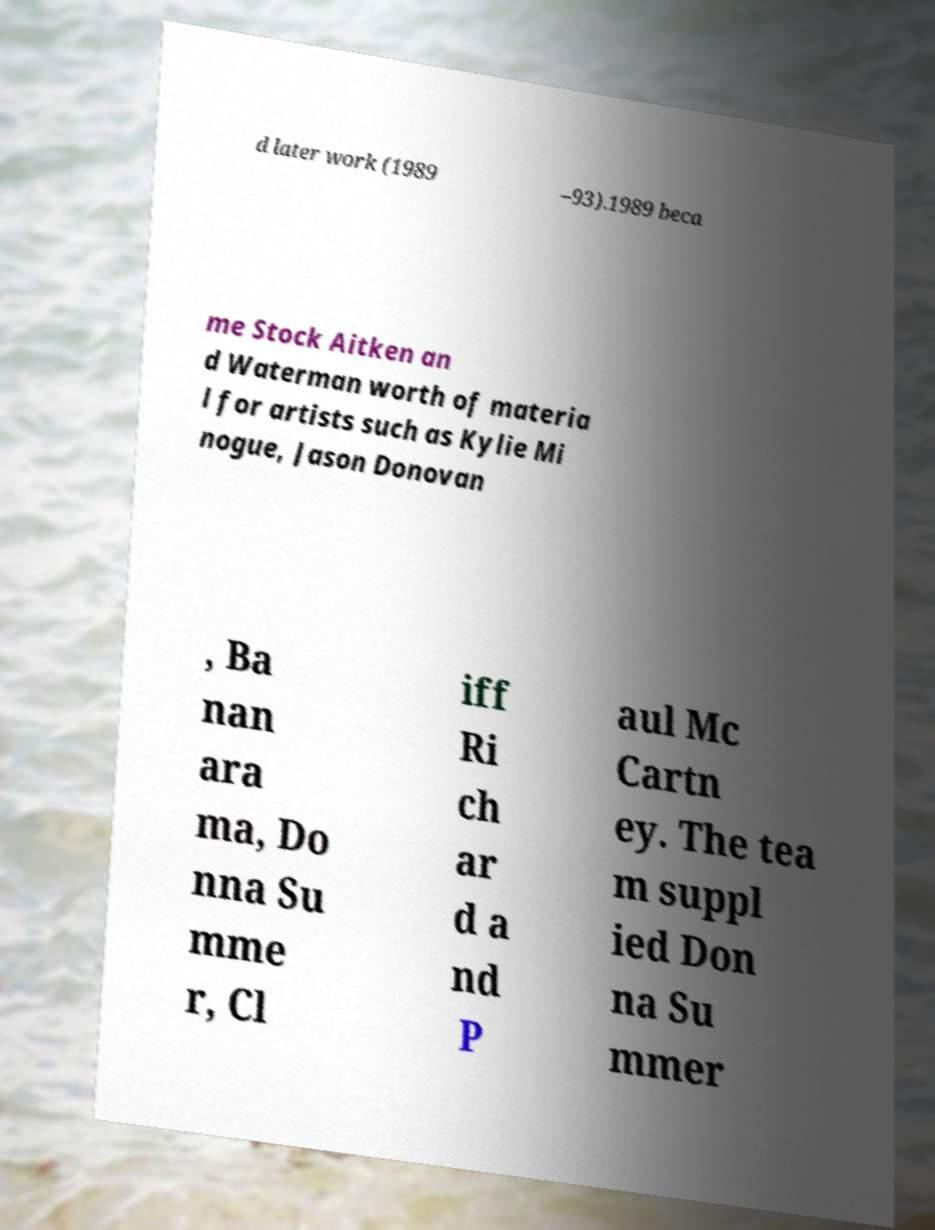I need the written content from this picture converted into text. Can you do that? d later work (1989 –93).1989 beca me Stock Aitken an d Waterman worth of materia l for artists such as Kylie Mi nogue, Jason Donovan , Ba nan ara ma, Do nna Su mme r, Cl iff Ri ch ar d a nd P aul Mc Cartn ey. The tea m suppl ied Don na Su mmer 